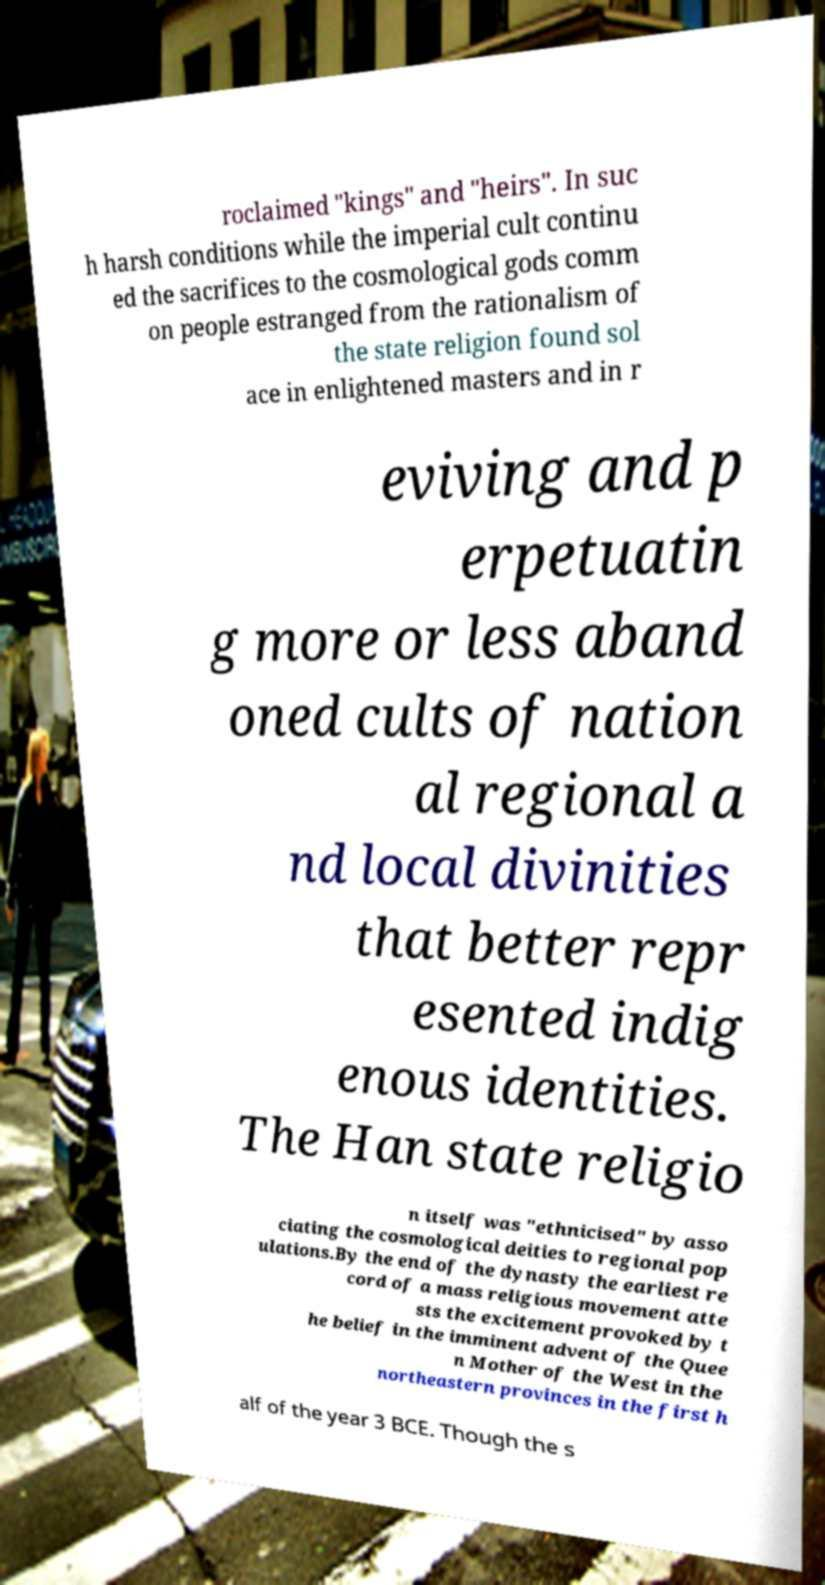Please identify and transcribe the text found in this image. roclaimed "kings" and "heirs". In suc h harsh conditions while the imperial cult continu ed the sacrifices to the cosmological gods comm on people estranged from the rationalism of the state religion found sol ace in enlightened masters and in r eviving and p erpetuatin g more or less aband oned cults of nation al regional a nd local divinities that better repr esented indig enous identities. The Han state religio n itself was "ethnicised" by asso ciating the cosmological deities to regional pop ulations.By the end of the dynasty the earliest re cord of a mass religious movement atte sts the excitement provoked by t he belief in the imminent advent of the Quee n Mother of the West in the northeastern provinces in the first h alf of the year 3 BCE. Though the s 